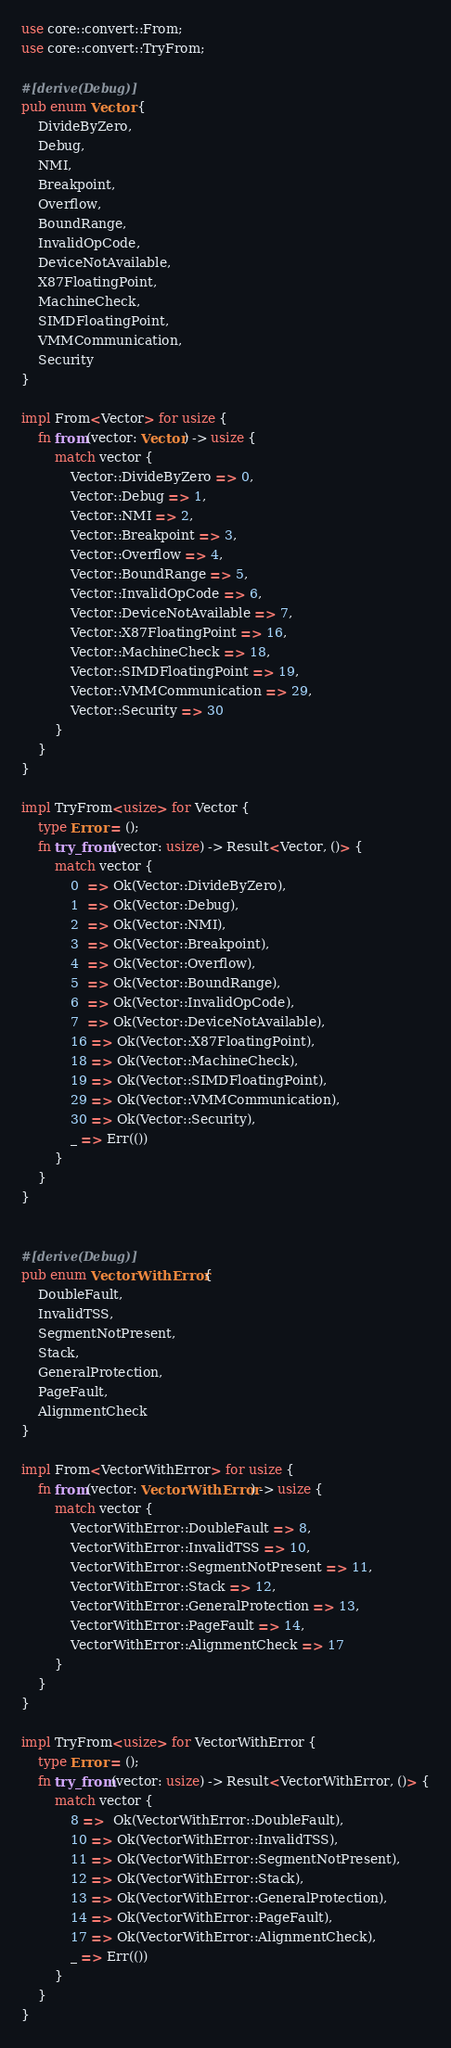Convert code to text. <code><loc_0><loc_0><loc_500><loc_500><_Rust_>use core::convert::From;
use core::convert::TryFrom;

#[derive(Debug)]
pub enum Vector {
    DivideByZero,
    Debug,
    NMI,
    Breakpoint,
    Overflow,
    BoundRange,
    InvalidOpCode,
    DeviceNotAvailable,
    X87FloatingPoint,
    MachineCheck,
    SIMDFloatingPoint,
    VMMCommunication,
    Security
}

impl From<Vector> for usize {
    fn from(vector: Vector) -> usize {
        match vector {
            Vector::DivideByZero => 0,
            Vector::Debug => 1,
            Vector::NMI => 2,
            Vector::Breakpoint => 3,
            Vector::Overflow => 4,
            Vector::BoundRange => 5,
            Vector::InvalidOpCode => 6,
            Vector::DeviceNotAvailable => 7,
            Vector::X87FloatingPoint => 16,
            Vector::MachineCheck => 18,
            Vector::SIMDFloatingPoint => 19,
            Vector::VMMCommunication => 29,
            Vector::Security => 30
        }
    }
}

impl TryFrom<usize> for Vector {
    type Error = ();
    fn try_from(vector: usize) -> Result<Vector, ()> {
        match vector {
            0  => Ok(Vector::DivideByZero),
            1  => Ok(Vector::Debug),
            2  => Ok(Vector::NMI),
            3  => Ok(Vector::Breakpoint),
            4  => Ok(Vector::Overflow),
            5  => Ok(Vector::BoundRange),
            6  => Ok(Vector::InvalidOpCode),
            7  => Ok(Vector::DeviceNotAvailable),
            16 => Ok(Vector::X87FloatingPoint),
            18 => Ok(Vector::MachineCheck),
            19 => Ok(Vector::SIMDFloatingPoint),
            29 => Ok(Vector::VMMCommunication),
            30 => Ok(Vector::Security),
            _ => Err(())
        }
    }
}


#[derive(Debug)]
pub enum VectorWithError {
    DoubleFault,
    InvalidTSS,
    SegmentNotPresent,
    Stack,
    GeneralProtection,
    PageFault,
    AlignmentCheck
}

impl From<VectorWithError> for usize {
    fn from(vector: VectorWithError) -> usize {
        match vector {
            VectorWithError::DoubleFault => 8,
            VectorWithError::InvalidTSS => 10,
            VectorWithError::SegmentNotPresent => 11,
            VectorWithError::Stack => 12,
            VectorWithError::GeneralProtection => 13,
            VectorWithError::PageFault => 14,
            VectorWithError::AlignmentCheck => 17
        }
    }
}

impl TryFrom<usize> for VectorWithError {
    type Error = ();
    fn try_from(vector: usize) -> Result<VectorWithError, ()> {
        match vector {
            8 =>  Ok(VectorWithError::DoubleFault),
            10 => Ok(VectorWithError::InvalidTSS),
            11 => Ok(VectorWithError::SegmentNotPresent),
            12 => Ok(VectorWithError::Stack),
            13 => Ok(VectorWithError::GeneralProtection),
            14 => Ok(VectorWithError::PageFault),
            17 => Ok(VectorWithError::AlignmentCheck),
            _ => Err(())
        }
    }
}

</code> 